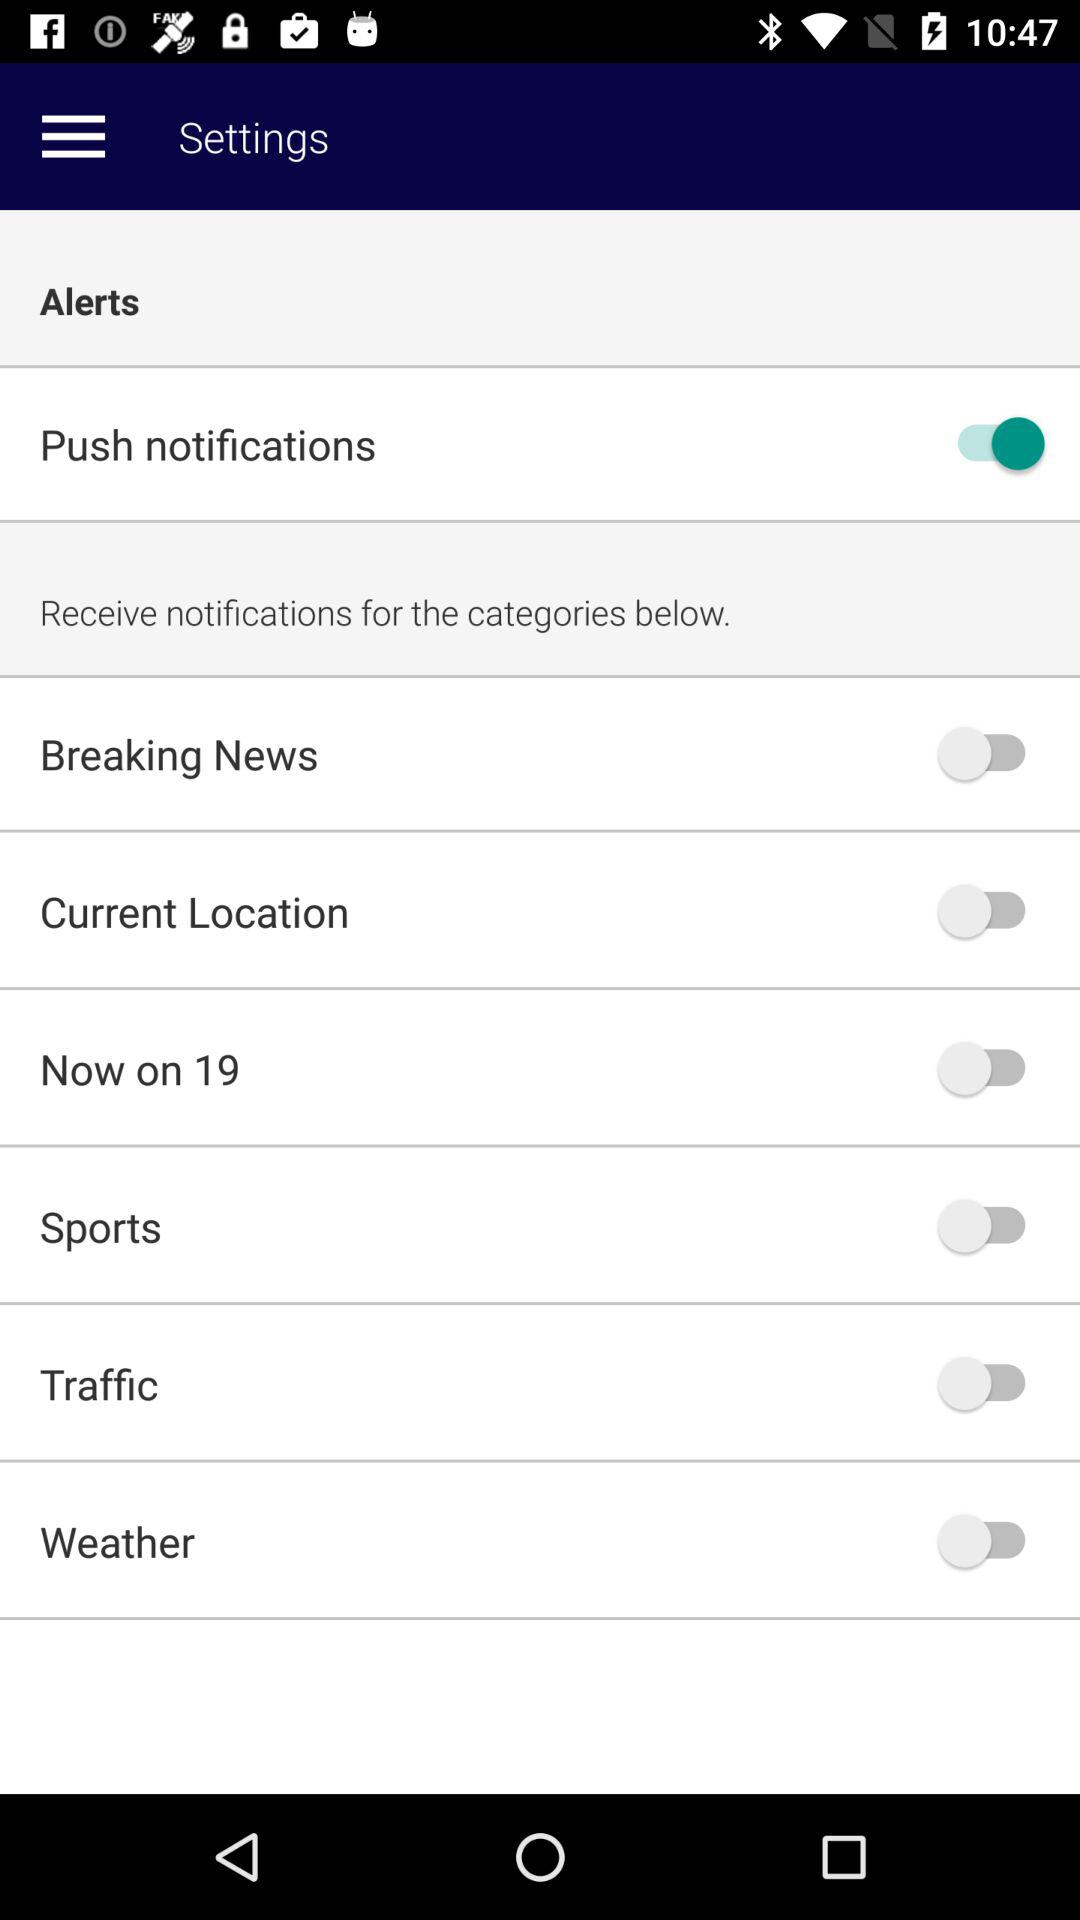What is the status of "Push notifications"? The status of "Push notifications" is "on". 